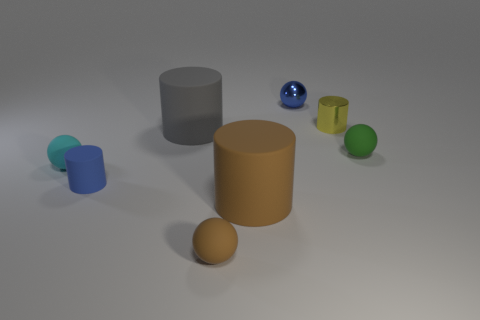Is the shape of the small yellow shiny object the same as the big brown object?
Provide a short and direct response. Yes. What size is the cyan matte thing that is the same shape as the green rubber object?
Provide a succinct answer. Small. Does the brown cylinder left of the green sphere have the same size as the cyan ball?
Your answer should be very brief. No. There is a sphere that is both in front of the small blue sphere and to the right of the big brown cylinder; how big is it?
Give a very brief answer. Small. There is a ball that is the same color as the tiny rubber cylinder; what is its material?
Keep it short and to the point. Metal. What number of other cylinders are the same color as the small rubber cylinder?
Provide a succinct answer. 0. Are there an equal number of small cyan rubber things that are to the left of the small green rubber sphere and gray shiny cubes?
Offer a terse response. No. What is the color of the small shiny sphere?
Give a very brief answer. Blue. There is a cyan sphere that is the same material as the gray cylinder; what is its size?
Provide a succinct answer. Small. The small cylinder that is made of the same material as the green ball is what color?
Offer a terse response. Blue. 